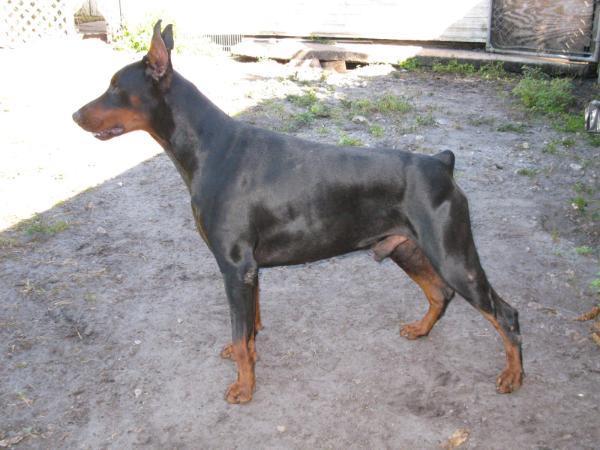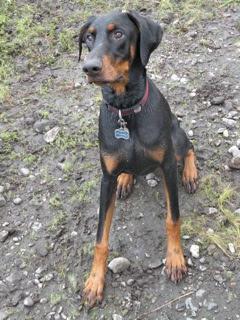The first image is the image on the left, the second image is the image on the right. Analyze the images presented: Is the assertion "The dogs in both images are lying down." valid? Answer yes or no. No. The first image is the image on the left, the second image is the image on the right. For the images shown, is this caption "In the right image, there's a Doberman sitting down." true? Answer yes or no. Yes. 